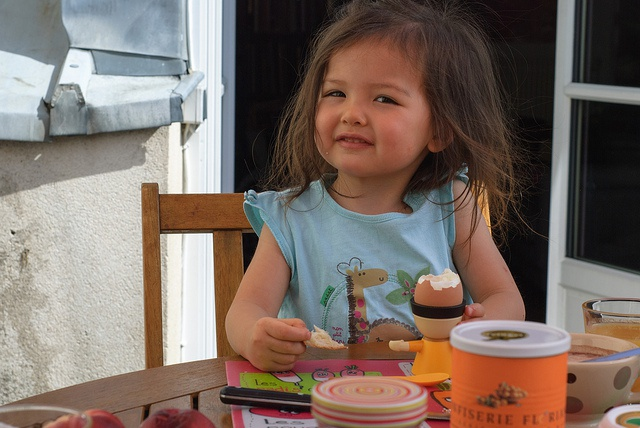Describe the objects in this image and their specific colors. I can see people in gray, brown, black, and maroon tones, dining table in gray, brown, and darkgray tones, chair in gray, white, maroon, and brown tones, bowl in gray, brown, and tan tones, and knife in gray, black, brown, and olive tones in this image. 